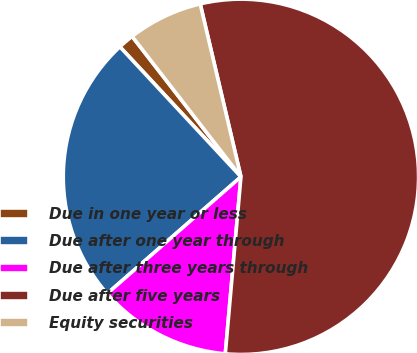Convert chart. <chart><loc_0><loc_0><loc_500><loc_500><pie_chart><fcel>Due in one year or less<fcel>Due after one year through<fcel>Due after three years through<fcel>Due after five years<fcel>Equity securities<nl><fcel>1.44%<fcel>24.5%<fcel>12.17%<fcel>55.09%<fcel>6.81%<nl></chart> 